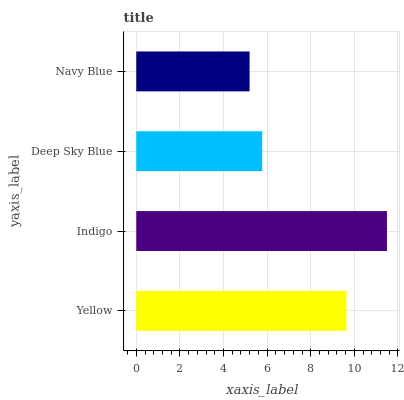Is Navy Blue the minimum?
Answer yes or no. Yes. Is Indigo the maximum?
Answer yes or no. Yes. Is Deep Sky Blue the minimum?
Answer yes or no. No. Is Deep Sky Blue the maximum?
Answer yes or no. No. Is Indigo greater than Deep Sky Blue?
Answer yes or no. Yes. Is Deep Sky Blue less than Indigo?
Answer yes or no. Yes. Is Deep Sky Blue greater than Indigo?
Answer yes or no. No. Is Indigo less than Deep Sky Blue?
Answer yes or no. No. Is Yellow the high median?
Answer yes or no. Yes. Is Deep Sky Blue the low median?
Answer yes or no. Yes. Is Deep Sky Blue the high median?
Answer yes or no. No. Is Indigo the low median?
Answer yes or no. No. 